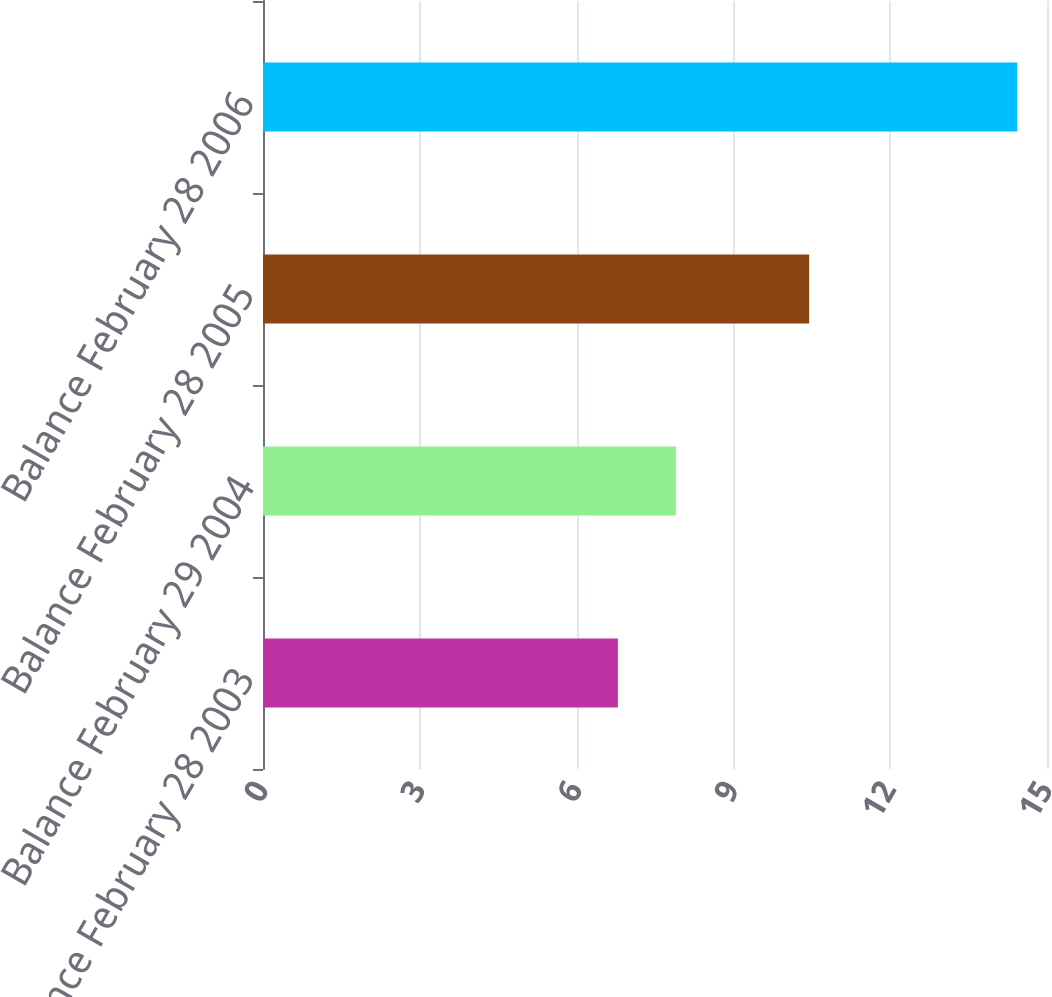Convert chart. <chart><loc_0><loc_0><loc_500><loc_500><bar_chart><fcel>Balance February 28 2003<fcel>Balance February 29 2004<fcel>Balance February 28 2005<fcel>Balance February 28 2006<nl><fcel>6.79<fcel>7.9<fcel>10.45<fcel>14.43<nl></chart> 